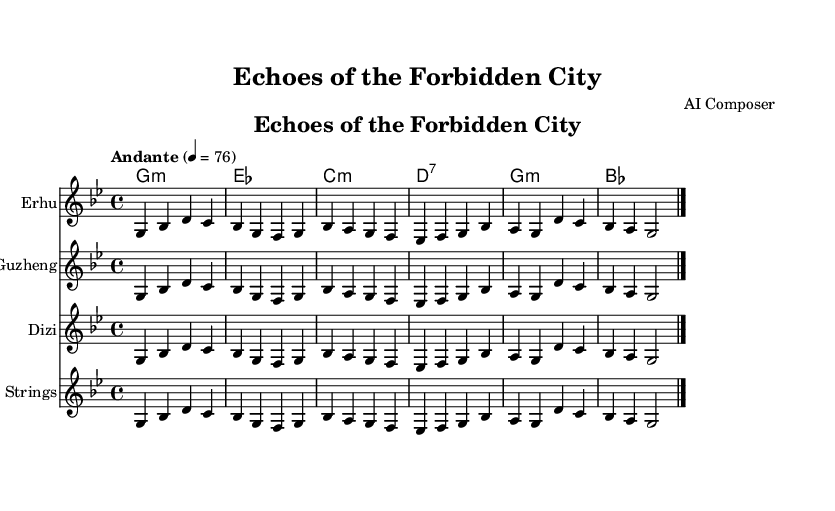What is the title of this piece? The title is indicated in the header section of the sheet music, which is labeled as "title." It is specifically written as "Echoes of the Forbidden City."
Answer: Echoes of the Forbidden City What is the key signature of this music? The key signature is found in the global settings of the sheet and is indicated by the letter casing. The piece is written in G minor, which has two flats.
Answer: G minor What is the time signature of this composition? The time signature is specified in the global settings of the music. Here, it is written as 4 over 4 in the code, indicating that there are four beats per measure.
Answer: 4/4 What instruments are featured in this composition? The instruments are listed in the score sections under each staff. They are Erhu, Guzheng, Dizi, and Strings.
Answer: Erhu, Guzheng, Dizi, Strings What is the tempo marking for this piece? The tempo is indicated in the global settings and is labeled as "Andante," which means moderately slow. It also specifies a metronome marking of 76 beats per minute.
Answer: Andante How many measures are there in this melody section? By counting the measures in the melody line from the provided music data, we find there are six distinct measures before the final double bar line.
Answer: Six Which chord appears first in the harmonies? The first chord in the harmonies section is specified as "g1:m," indicating a G minor chord. This can be found at the start of the chord progression and represents the root of the harmony.
Answer: G minor 